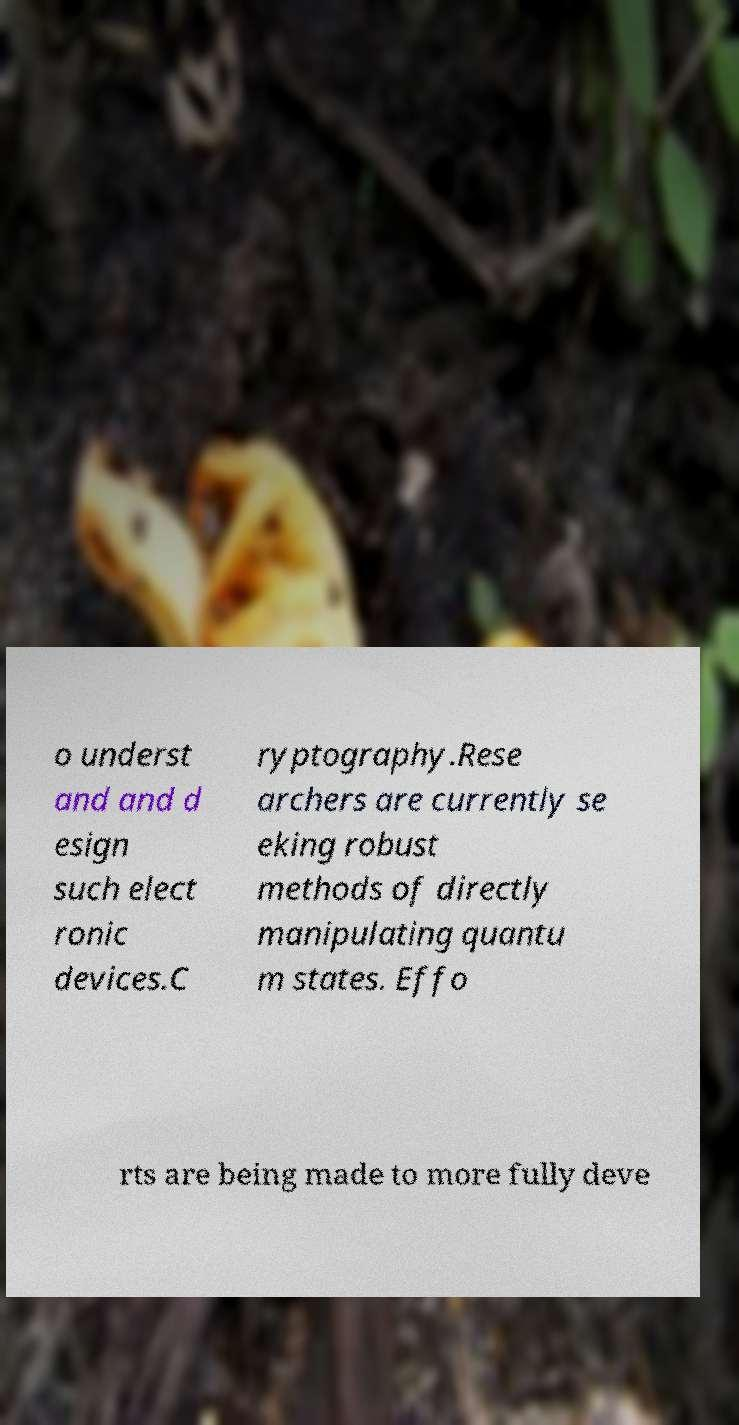Can you read and provide the text displayed in the image?This photo seems to have some interesting text. Can you extract and type it out for me? o underst and and d esign such elect ronic devices.C ryptography.Rese archers are currently se eking robust methods of directly manipulating quantu m states. Effo rts are being made to more fully deve 